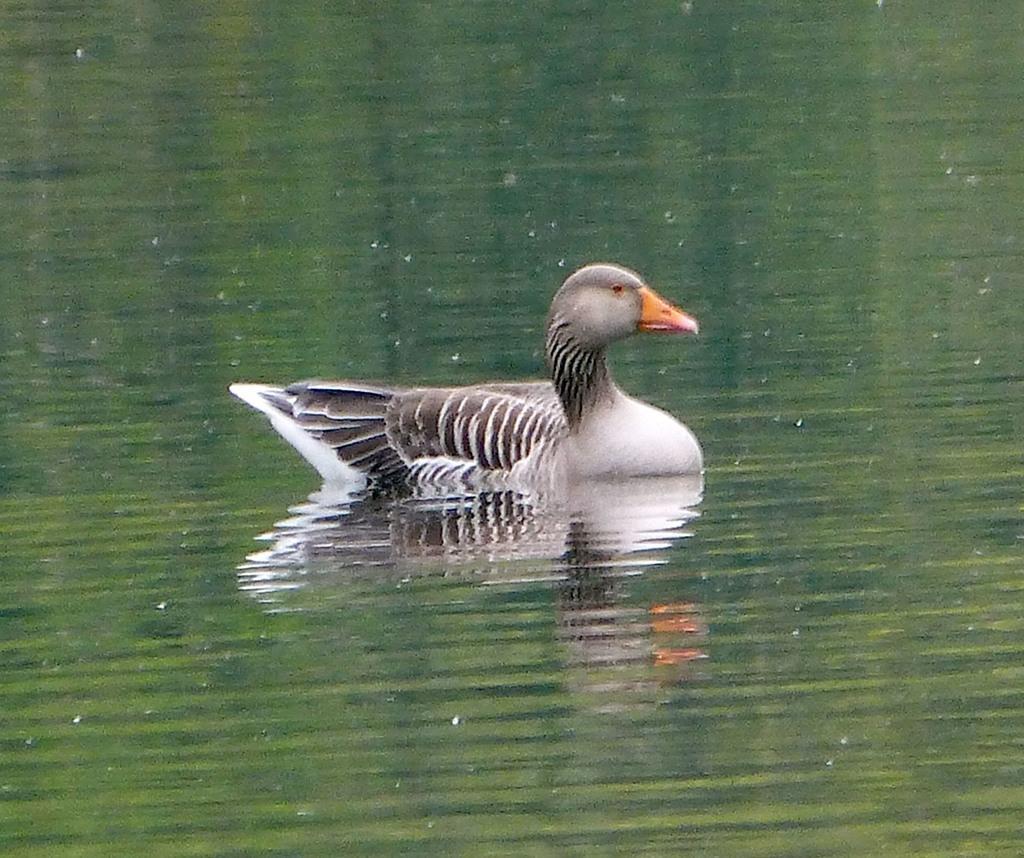Please provide a concise description of this image. There is a black and white duck with a orange beak is swimming in the water. 